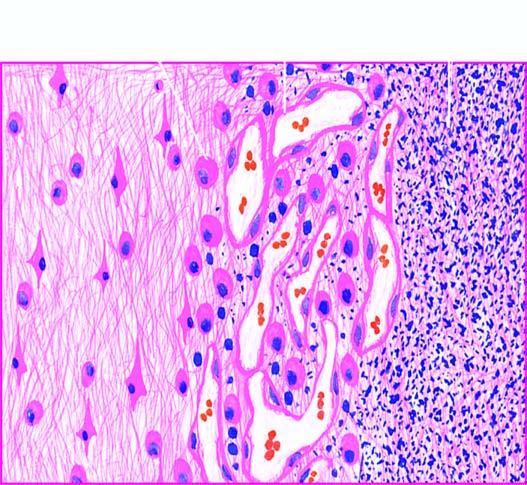what shows a cystic space containing cell debris, while the surrounding zone shows granulation tissue and gliosis?
Answer the question using a single word or phrase. Necrosed area right side of field esurrounding gliosis 